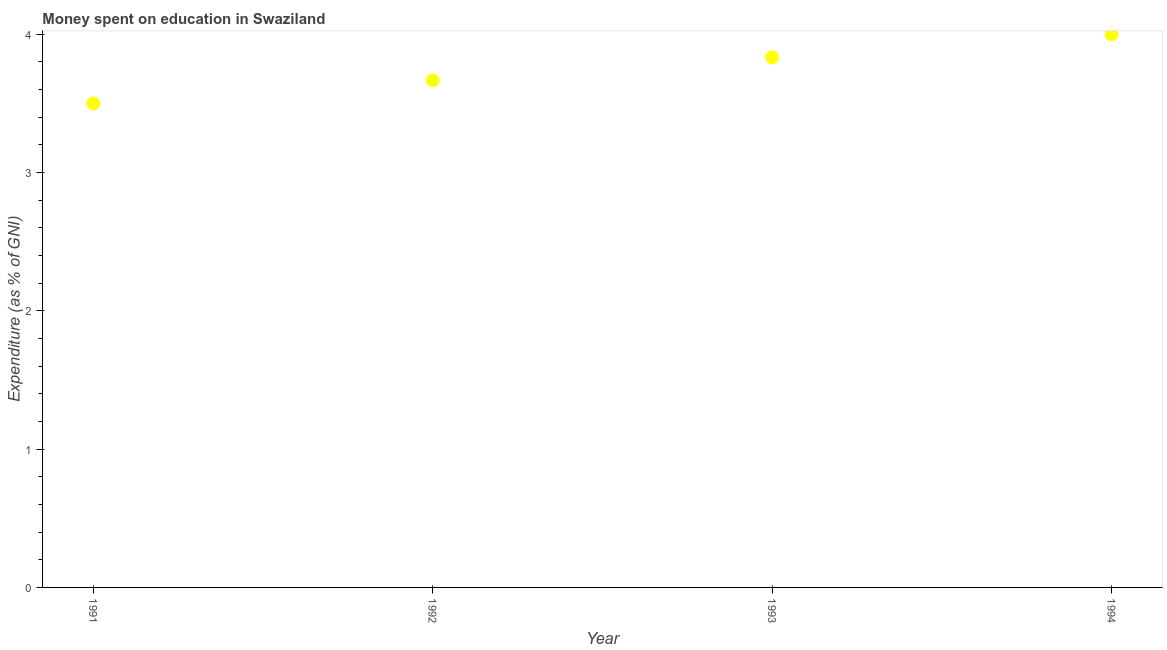What is the expenditure on education in 1993?
Offer a very short reply. 3.83. What is the sum of the expenditure on education?
Provide a short and direct response. 15. What is the difference between the expenditure on education in 1991 and 1993?
Your answer should be compact. -0.33. What is the average expenditure on education per year?
Give a very brief answer. 3.75. What is the median expenditure on education?
Your response must be concise. 3.75. What is the ratio of the expenditure on education in 1991 to that in 1993?
Your answer should be very brief. 0.91. Is the expenditure on education in 1991 less than that in 1994?
Your answer should be very brief. Yes. What is the difference between the highest and the second highest expenditure on education?
Your response must be concise. 0.17. Is the sum of the expenditure on education in 1993 and 1994 greater than the maximum expenditure on education across all years?
Provide a succinct answer. Yes. How many dotlines are there?
Keep it short and to the point. 1. Are the values on the major ticks of Y-axis written in scientific E-notation?
Your answer should be compact. No. Does the graph contain any zero values?
Your answer should be very brief. No. What is the title of the graph?
Offer a very short reply. Money spent on education in Swaziland. What is the label or title of the Y-axis?
Provide a succinct answer. Expenditure (as % of GNI). What is the Expenditure (as % of GNI) in 1992?
Provide a succinct answer. 3.67. What is the Expenditure (as % of GNI) in 1993?
Make the answer very short. 3.83. What is the Expenditure (as % of GNI) in 1994?
Offer a terse response. 4. What is the difference between the Expenditure (as % of GNI) in 1991 and 1992?
Your response must be concise. -0.17. What is the difference between the Expenditure (as % of GNI) in 1991 and 1993?
Give a very brief answer. -0.33. What is the difference between the Expenditure (as % of GNI) in 1991 and 1994?
Your response must be concise. -0.5. What is the difference between the Expenditure (as % of GNI) in 1992 and 1993?
Provide a short and direct response. -0.17. What is the difference between the Expenditure (as % of GNI) in 1992 and 1994?
Offer a terse response. -0.33. What is the difference between the Expenditure (as % of GNI) in 1993 and 1994?
Your answer should be compact. -0.17. What is the ratio of the Expenditure (as % of GNI) in 1991 to that in 1992?
Your answer should be compact. 0.95. What is the ratio of the Expenditure (as % of GNI) in 1991 to that in 1994?
Your answer should be very brief. 0.88. What is the ratio of the Expenditure (as % of GNI) in 1992 to that in 1994?
Your answer should be compact. 0.92. What is the ratio of the Expenditure (as % of GNI) in 1993 to that in 1994?
Your answer should be compact. 0.96. 